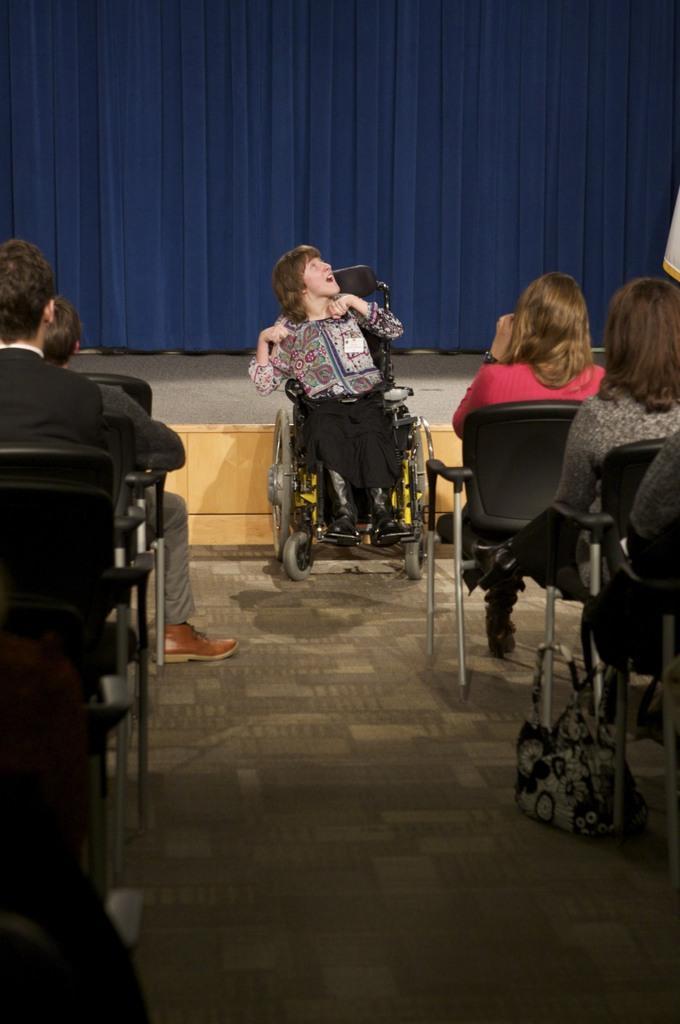Could you give a brief overview of what you see in this image? In the image there is a person sitting on a wheelchair and in front of that person there are some other people sitting on the chairs, in the background there is a stage and behind the stage there is a blue colour curtain. 